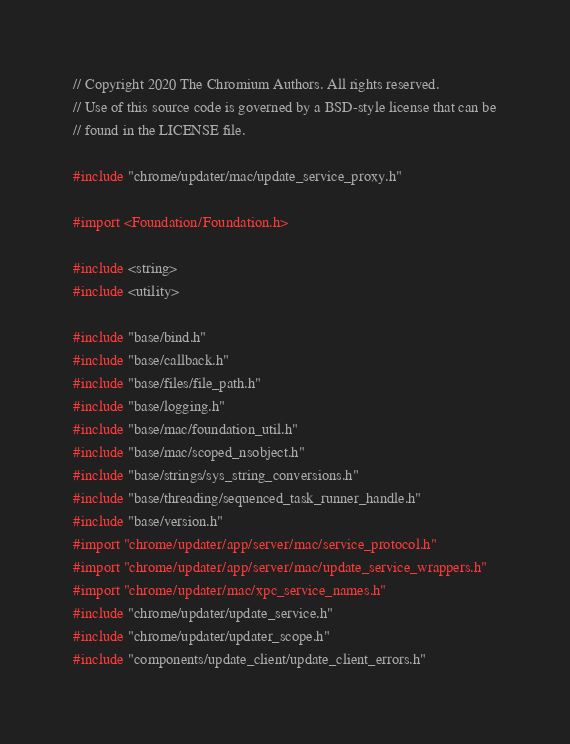<code> <loc_0><loc_0><loc_500><loc_500><_ObjectiveC_>// Copyright 2020 The Chromium Authors. All rights reserved.
// Use of this source code is governed by a BSD-style license that can be
// found in the LICENSE file.

#include "chrome/updater/mac/update_service_proxy.h"

#import <Foundation/Foundation.h>

#include <string>
#include <utility>

#include "base/bind.h"
#include "base/callback.h"
#include "base/files/file_path.h"
#include "base/logging.h"
#include "base/mac/foundation_util.h"
#include "base/mac/scoped_nsobject.h"
#include "base/strings/sys_string_conversions.h"
#include "base/threading/sequenced_task_runner_handle.h"
#include "base/version.h"
#import "chrome/updater/app/server/mac/service_protocol.h"
#import "chrome/updater/app/server/mac/update_service_wrappers.h"
#import "chrome/updater/mac/xpc_service_names.h"
#include "chrome/updater/update_service.h"
#include "chrome/updater/updater_scope.h"
#include "components/update_client/update_client_errors.h"
</code> 